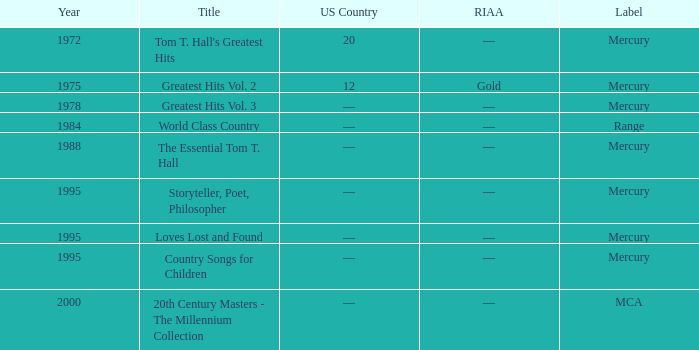What is the title of the record that received a riaa gold status? Greatest Hits Vol. 2. Give me the full table as a dictionary. {'header': ['Year', 'Title', 'US Country', 'RIAA', 'Label'], 'rows': [['1972', "Tom T. Hall's Greatest Hits", '20', '—', 'Mercury'], ['1975', 'Greatest Hits Vol. 2', '12', 'Gold', 'Mercury'], ['1978', 'Greatest Hits Vol. 3', '—', '—', 'Mercury'], ['1984', 'World Class Country', '—', '—', 'Range'], ['1988', 'The Essential Tom T. Hall', '—', '—', 'Mercury'], ['1995', 'Storyteller, Poet, Philosopher', '—', '—', 'Mercury'], ['1995', 'Loves Lost and Found', '—', '—', 'Mercury'], ['1995', 'Country Songs for Children', '—', '—', 'Mercury'], ['2000', '20th Century Masters - The Millennium Collection', '—', '—', 'MCA']]} 